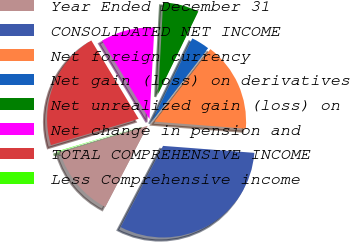<chart> <loc_0><loc_0><loc_500><loc_500><pie_chart><fcel>Year Ended December 31<fcel>CONSOLIDATED NET INCOME<fcel>Net foreign currency<fcel>Net gain (loss) on derivatives<fcel>Net unrealized gain (loss) on<fcel>Net change in pension and<fcel>TOTAL COMPREHENSIVE INCOME<fcel>Less Comprehensive income<nl><fcel>12.63%<fcel>31.44%<fcel>15.77%<fcel>3.23%<fcel>6.36%<fcel>9.5%<fcel>20.98%<fcel>0.09%<nl></chart> 